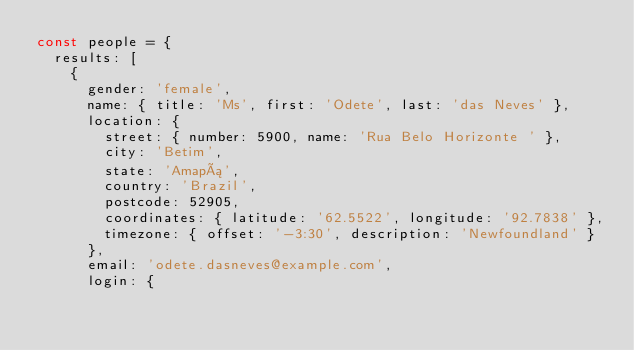<code> <loc_0><loc_0><loc_500><loc_500><_JavaScript_>const people = {
  results: [
    {
      gender: 'female',
      name: { title: 'Ms', first: 'Odete', last: 'das Neves' },
      location: {
        street: { number: 5900, name: 'Rua Belo Horizonte ' },
        city: 'Betim',
        state: 'Amapá',
        country: 'Brazil',
        postcode: 52905,
        coordinates: { latitude: '62.5522', longitude: '92.7838' },
        timezone: { offset: '-3:30', description: 'Newfoundland' }
      },
      email: 'odete.dasneves@example.com',
      login: {</code> 